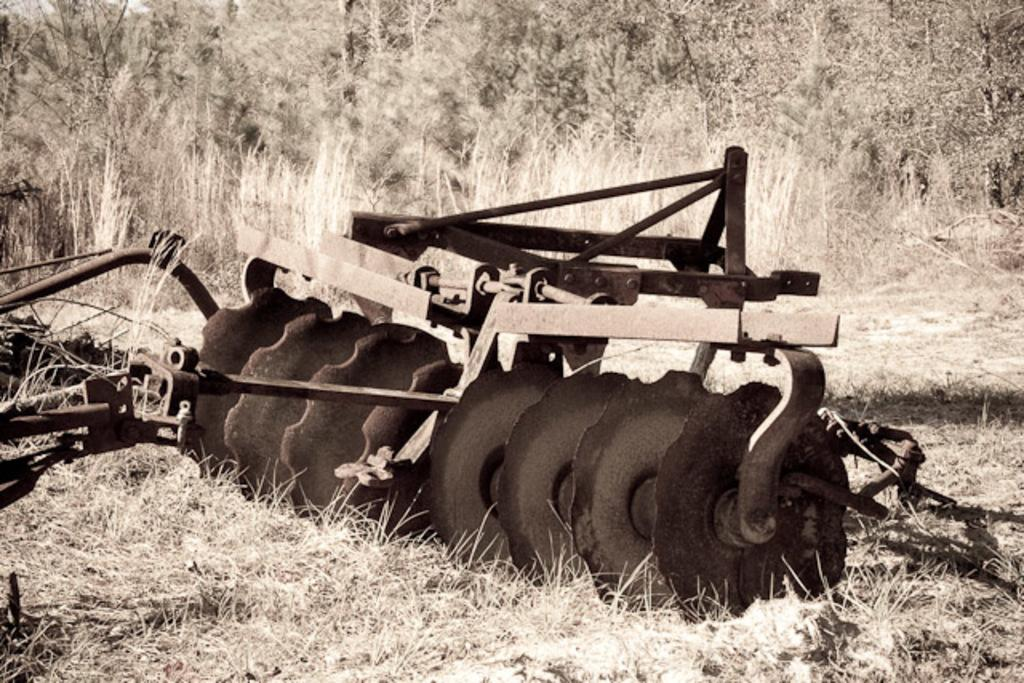What is the main subject in the image? There is a machine in the image. What type of natural environment is visible in the image? There is grass on the ground in the image. What can be seen in the background of the image? There are trees visible in the background of the image. What type of voyage is the machine embarking on in the image? The image does not depict a voyage, and the machine is stationary. What type of vest is the machine wearing in the image? The machine is not a living being and therefore cannot wear a vest. 